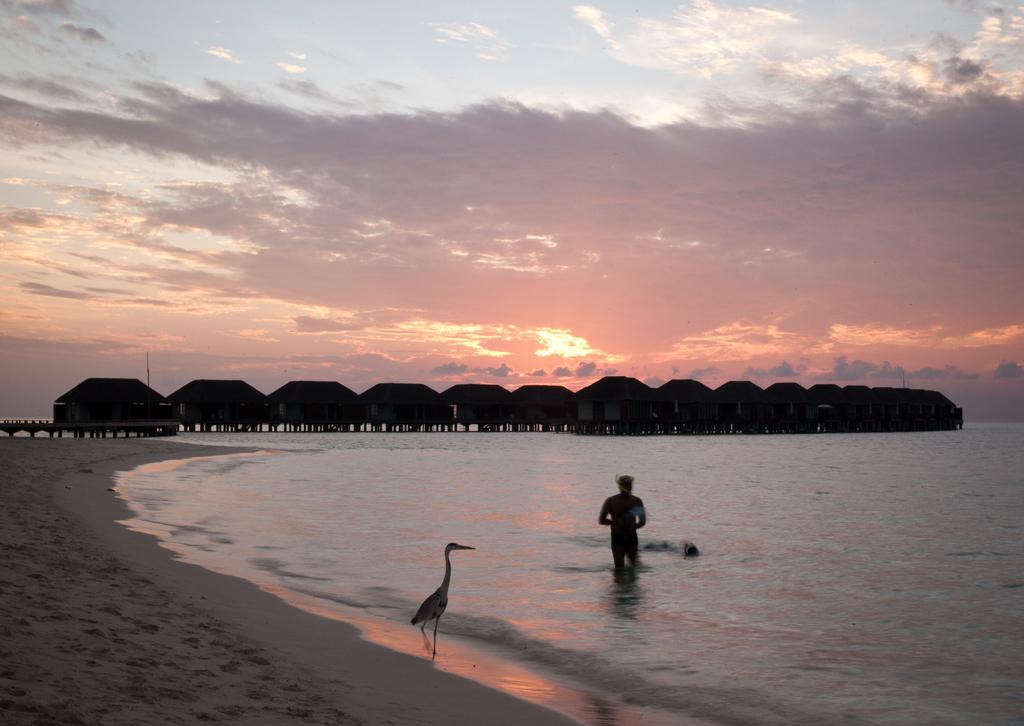What is the main subject in the image? There is a crane in the image. Where is the crane located? The crane is on a seashore. What else can be seen in the image besides the crane? There is a man in the sea and houses in the background of the image. What is visible in the background of the image? The sky is visible in the background of the image. What type of apple is being used to cover the man in the sea? There is no apple present in the image, and the man in the sea is not being covered by anything. 